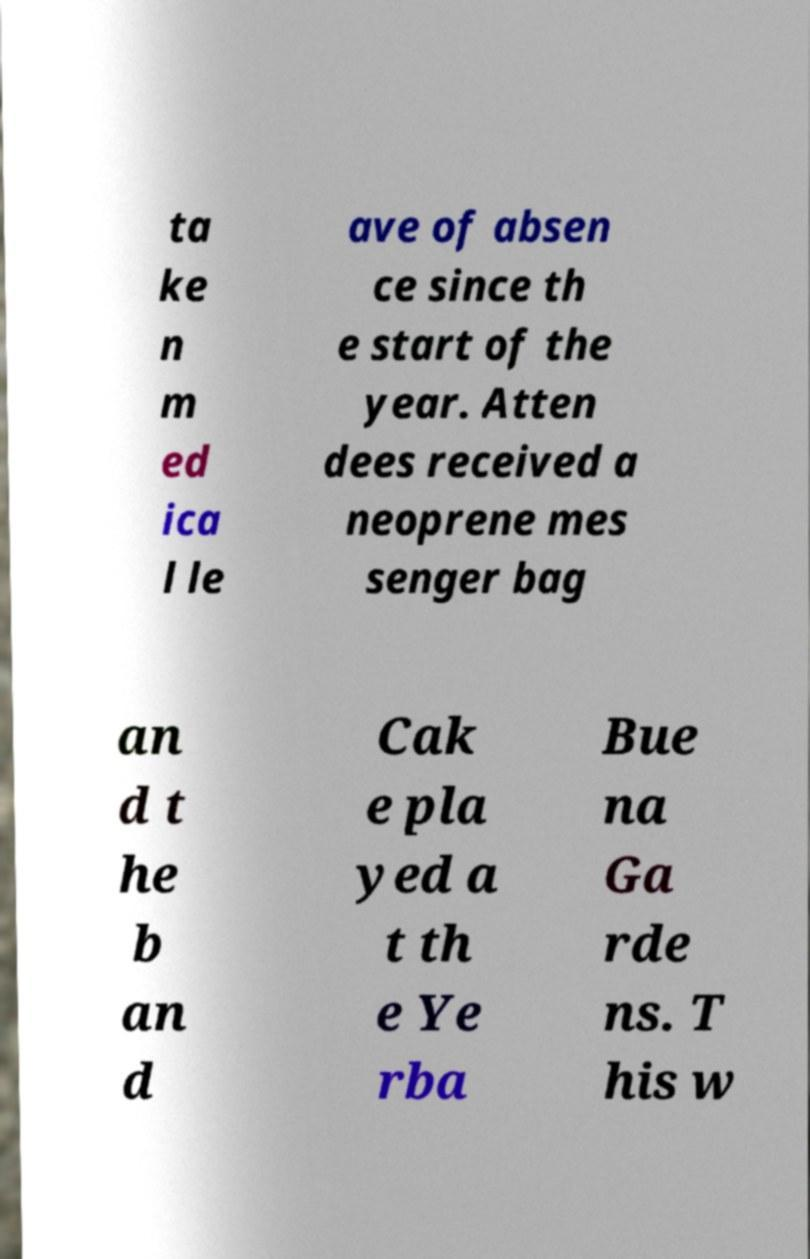What messages or text are displayed in this image? I need them in a readable, typed format. ta ke n m ed ica l le ave of absen ce since th e start of the year. Atten dees received a neoprene mes senger bag an d t he b an d Cak e pla yed a t th e Ye rba Bue na Ga rde ns. T his w 